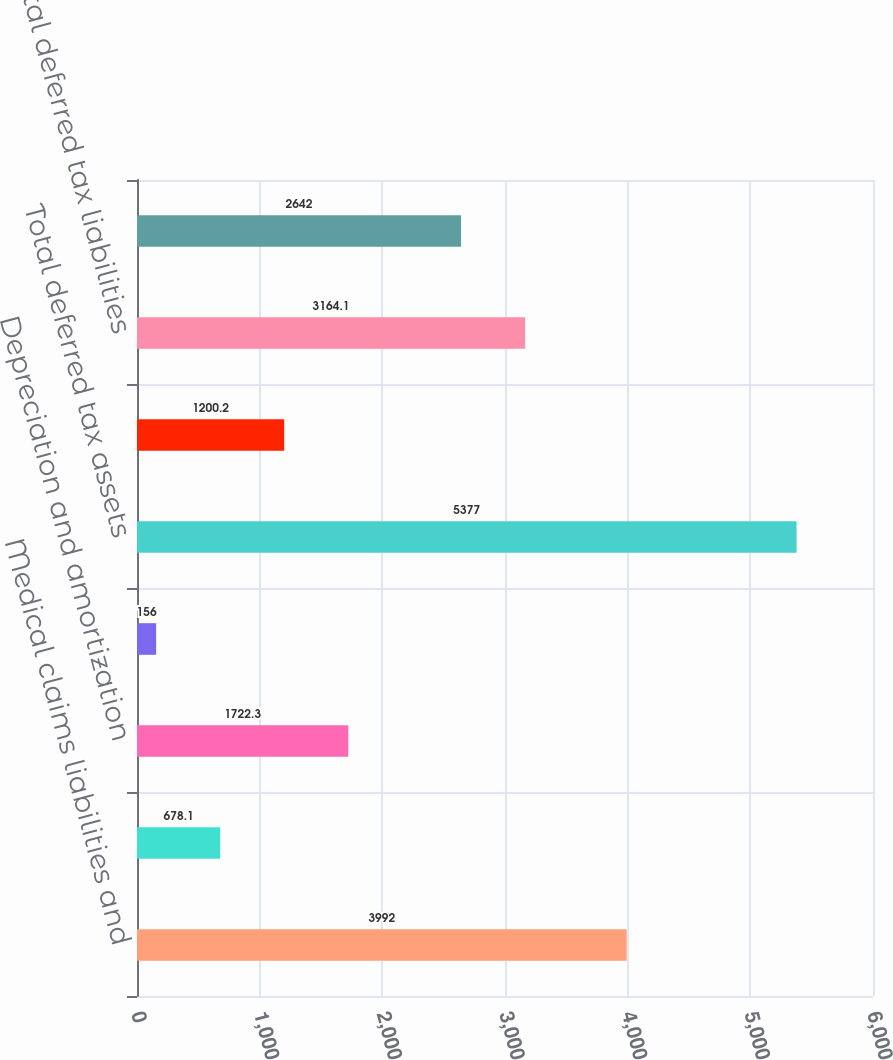<chart> <loc_0><loc_0><loc_500><loc_500><bar_chart><fcel>Medical claims liabilities and<fcel>Allowance for doubtful<fcel>Depreciation and amortization<fcel>Other<fcel>Total deferred tax assets<fcel>Unrealized gain on investments<fcel>Total deferred tax liabilities<fcel>Net deferred tax assets and<nl><fcel>3992<fcel>678.1<fcel>1722.3<fcel>156<fcel>5377<fcel>1200.2<fcel>3164.1<fcel>2642<nl></chart> 